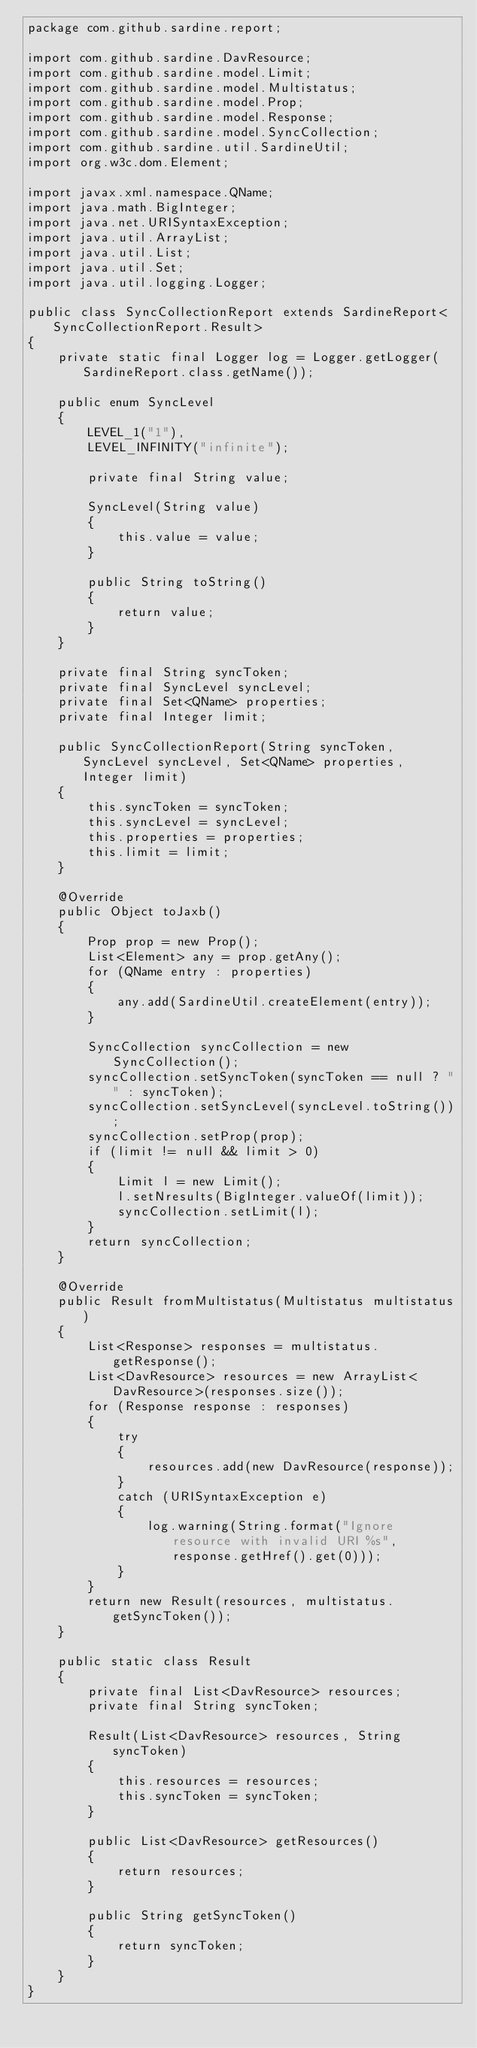Convert code to text. <code><loc_0><loc_0><loc_500><loc_500><_Java_>package com.github.sardine.report;

import com.github.sardine.DavResource;
import com.github.sardine.model.Limit;
import com.github.sardine.model.Multistatus;
import com.github.sardine.model.Prop;
import com.github.sardine.model.Response;
import com.github.sardine.model.SyncCollection;
import com.github.sardine.util.SardineUtil;
import org.w3c.dom.Element;

import javax.xml.namespace.QName;
import java.math.BigInteger;
import java.net.URISyntaxException;
import java.util.ArrayList;
import java.util.List;
import java.util.Set;
import java.util.logging.Logger;

public class SyncCollectionReport extends SardineReport<SyncCollectionReport.Result>
{
	private static final Logger log = Logger.getLogger(SardineReport.class.getName());

	public enum SyncLevel
	{
		LEVEL_1("1"),
		LEVEL_INFINITY("infinite");

		private final String value;

		SyncLevel(String value)
		{
			this.value = value;
		}

		public String toString()
		{
			return value;
		}
	}

	private final String syncToken;
	private final SyncLevel syncLevel;
	private final Set<QName> properties;
	private final Integer limit;

	public SyncCollectionReport(String syncToken, SyncLevel syncLevel, Set<QName> properties, Integer limit)
	{
		this.syncToken = syncToken;
		this.syncLevel = syncLevel;
		this.properties = properties;
		this.limit = limit;
	}

	@Override
	public Object toJaxb()
	{
		Prop prop = new Prop();
		List<Element> any = prop.getAny();
		for (QName entry : properties)
		{
			any.add(SardineUtil.createElement(entry));
		}

		SyncCollection syncCollection = new SyncCollection();
		syncCollection.setSyncToken(syncToken == null ? "" : syncToken);
		syncCollection.setSyncLevel(syncLevel.toString());
		syncCollection.setProp(prop);
		if (limit != null && limit > 0)
		{
			Limit l = new Limit();
			l.setNresults(BigInteger.valueOf(limit));
			syncCollection.setLimit(l);
		}
		return syncCollection;
	}

	@Override
	public Result fromMultistatus(Multistatus multistatus)
	{
		List<Response> responses = multistatus.getResponse();
		List<DavResource> resources = new ArrayList<DavResource>(responses.size());
		for (Response response : responses)
		{
			try
			{
				resources.add(new DavResource(response));
			}
			catch (URISyntaxException e)
			{
				log.warning(String.format("Ignore resource with invalid URI %s", response.getHref().get(0)));
			}
		}
		return new Result(resources, multistatus.getSyncToken());
	}

	public static class Result
	{
		private final List<DavResource> resources;
		private final String syncToken;

		Result(List<DavResource> resources, String syncToken)
		{
			this.resources = resources;
			this.syncToken = syncToken;
		}

		public List<DavResource> getResources()
		{
			return resources;
		}

		public String getSyncToken()
		{
			return syncToken;
		}
	}
}
</code> 